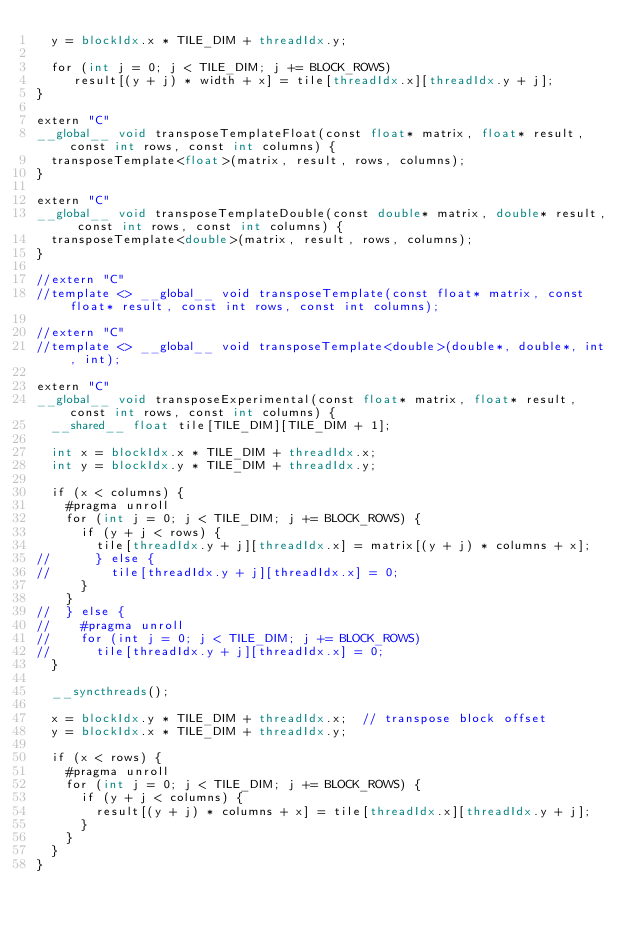<code> <loc_0><loc_0><loc_500><loc_500><_Cuda_>  y = blockIdx.x * TILE_DIM + threadIdx.y;

  for (int j = 0; j < TILE_DIM; j += BLOCK_ROWS)
     result[(y + j) * width + x] = tile[threadIdx.x][threadIdx.y + j];
}

extern "C"
__global__ void transposeTemplateFloat(const float* matrix, float* result, const int rows, const int columns) {
  transposeTemplate<float>(matrix, result, rows, columns);
}

extern "C"
__global__ void transposeTemplateDouble(const double* matrix, double* result, const int rows, const int columns) {
  transposeTemplate<double>(matrix, result, rows, columns);
}

//extern "C"
//template <> __global__ void transposeTemplate(const float* matrix, const float* result, const int rows, const int columns);

//extern "C"
//template <> __global__ void transposeTemplate<double>(double*, double*, int, int);

extern "C"
__global__ void transposeExperimental(const float* matrix, float* result, const int rows, const int columns) {
  __shared__ float tile[TILE_DIM][TILE_DIM + 1];

  int x = blockIdx.x * TILE_DIM + threadIdx.x;
  int y = blockIdx.y * TILE_DIM + threadIdx.y;

  if (x < columns) {
    #pragma unroll
    for (int j = 0; j < TILE_DIM; j += BLOCK_ROWS) {
      if (y + j < rows) {
        tile[threadIdx.y + j][threadIdx.x] = matrix[(y + j) * columns + x];
//      } else {
//        tile[threadIdx.y + j][threadIdx.x] = 0;
      }
    }
//  } else {
//    #pragma unroll
//    for (int j = 0; j < TILE_DIM; j += BLOCK_ROWS)
//      tile[threadIdx.y + j][threadIdx.x] = 0;
  }

  __syncthreads();

  x = blockIdx.y * TILE_DIM + threadIdx.x;  // transpose block offset
  y = blockIdx.x * TILE_DIM + threadIdx.y;

  if (x < rows) {
    #pragma unroll
    for (int j = 0; j < TILE_DIM; j += BLOCK_ROWS) {
      if (y + j < columns) {
        result[(y + j) * columns + x] = tile[threadIdx.x][threadIdx.y + j];
      }
    }
  }
}</code> 